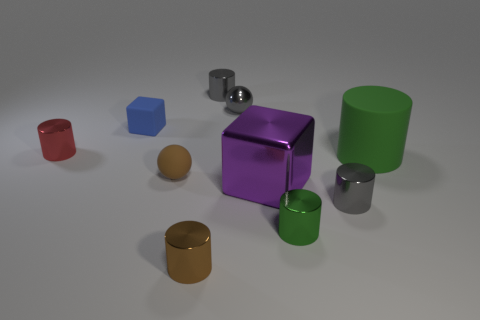Subtract all large rubber cylinders. How many cylinders are left? 5 Subtract all purple blocks. How many blocks are left? 1 Subtract 1 cubes. How many cubes are left? 1 Subtract all red balls. Subtract all purple cylinders. How many balls are left? 2 Subtract all cyan cylinders. How many purple cubes are left? 1 Subtract all metallic balls. Subtract all tiny brown cylinders. How many objects are left? 8 Add 5 tiny gray balls. How many tiny gray balls are left? 6 Add 8 big purple shiny blocks. How many big purple shiny blocks exist? 9 Subtract 1 green cylinders. How many objects are left? 9 Subtract all spheres. How many objects are left? 8 